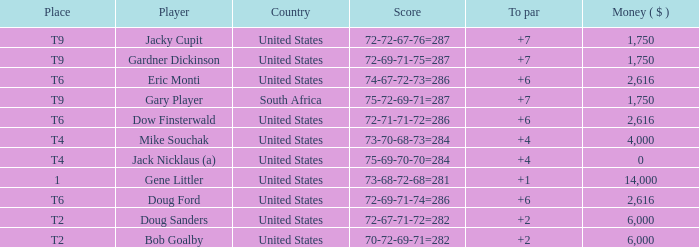What is the average To Par, when Score is "72-67-71-72=282"? 2.0. 